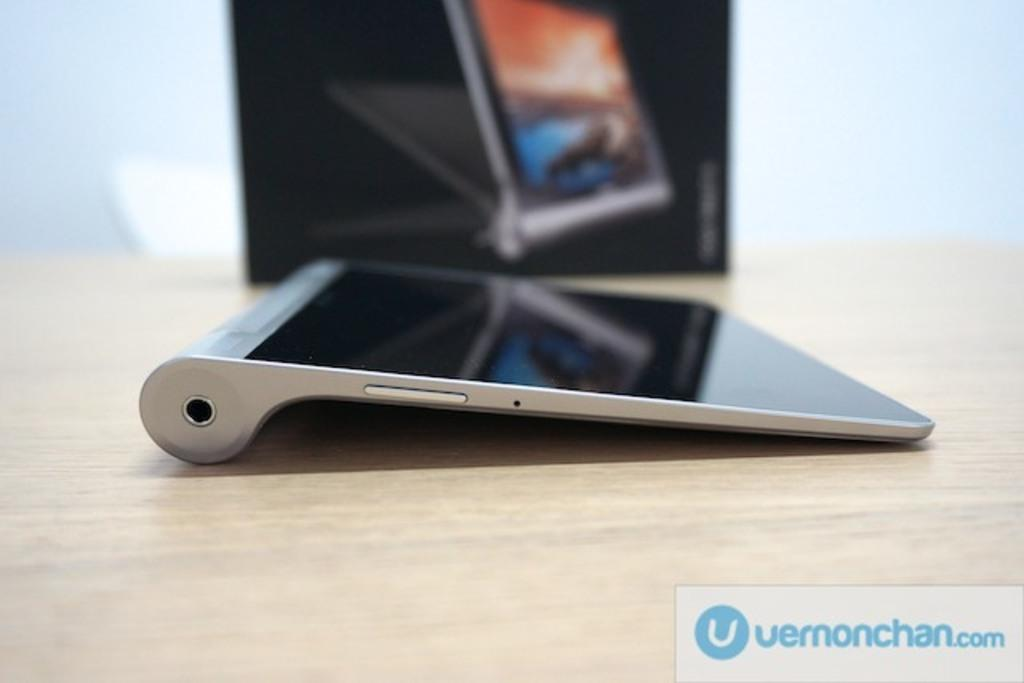<image>
Create a compact narrative representing the image presented. Tablets are available for sale at Vernonchan's website. 